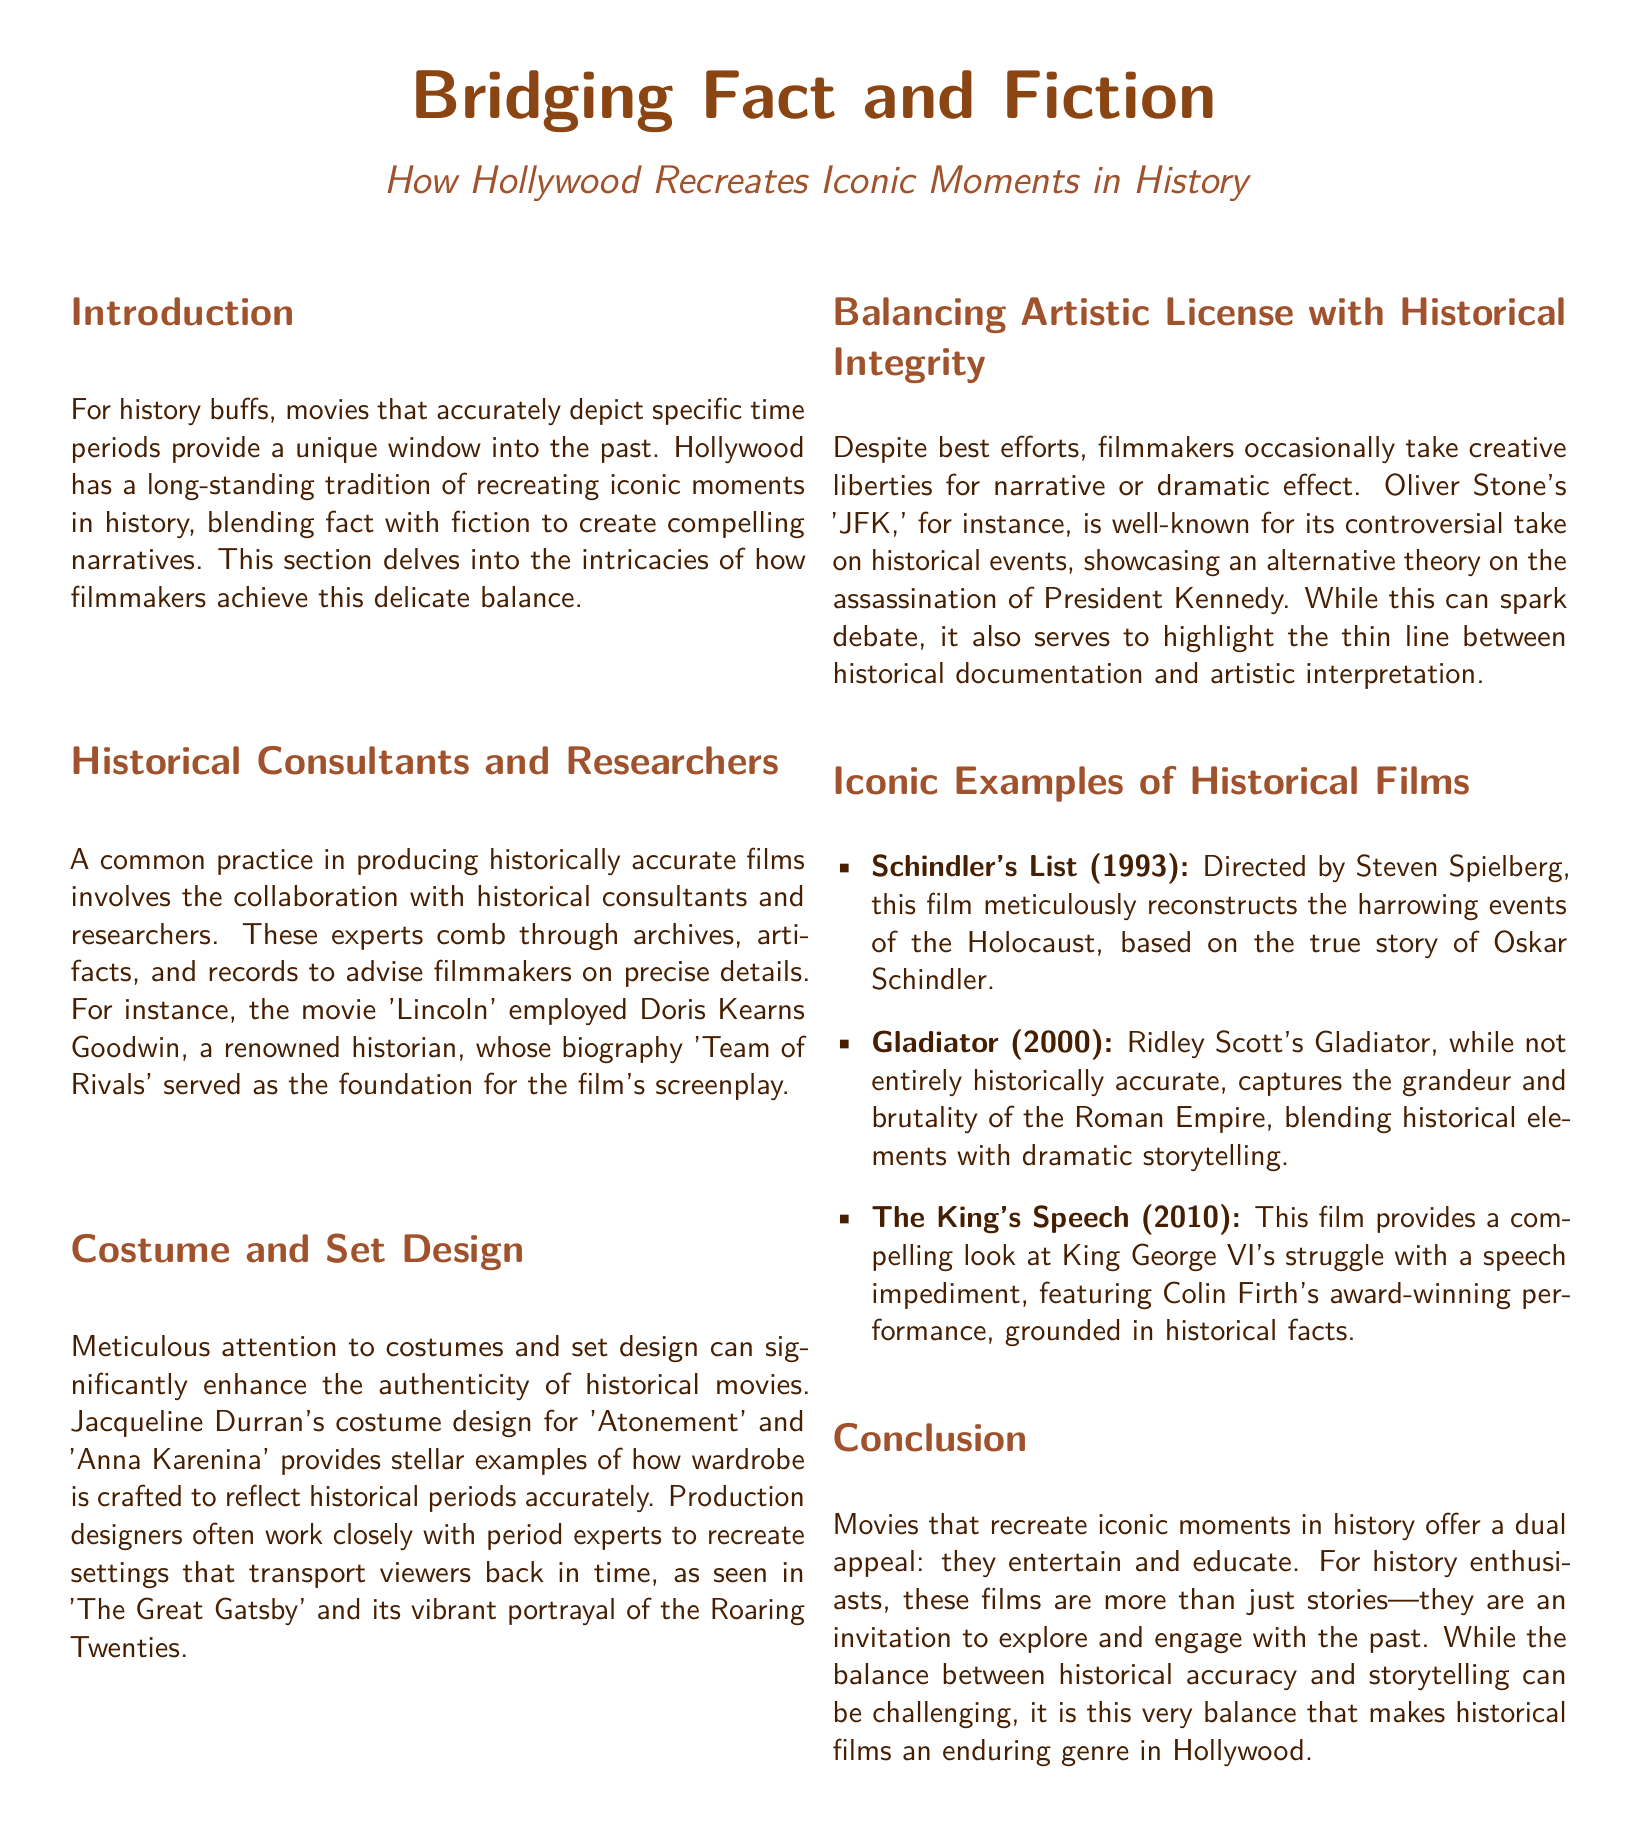what is the title of the document? The title of the document is presented prominently at the top of the layout.
Answer: Bridging Fact and Fiction who was the historical consultant for the movie 'Lincoln'? The document mentions the renowned historian associated with the film, providing their name.
Answer: Doris Kearns Goodwin what year was 'Schindler's List' released? The document specifies the release year of the film as part of its iconic examples section.
Answer: 1993 which film showcases King George VI's struggle with a speech impediment? The document includes information about a film focused on this historical figure.
Answer: The King's Speech what is a notable film that depicts the Roman Empire? The document offers examples of films blending historical elements with storytelling, including one about the Roman Empire.
Answer: Gladiator how many films are specifically mentioned in the iconic examples section? The document lists a specific number of films in the examples section, which can be counted.
Answer: three what color is used for the section titles? The document indicates a specific color used for the titles of sections.
Answer: RGB 160, 82, 45 what does the conclusion emphasize about historical films? The conclusion summarizes the appeal of historical films, stating their dual purpose.
Answer: entertain and educate 